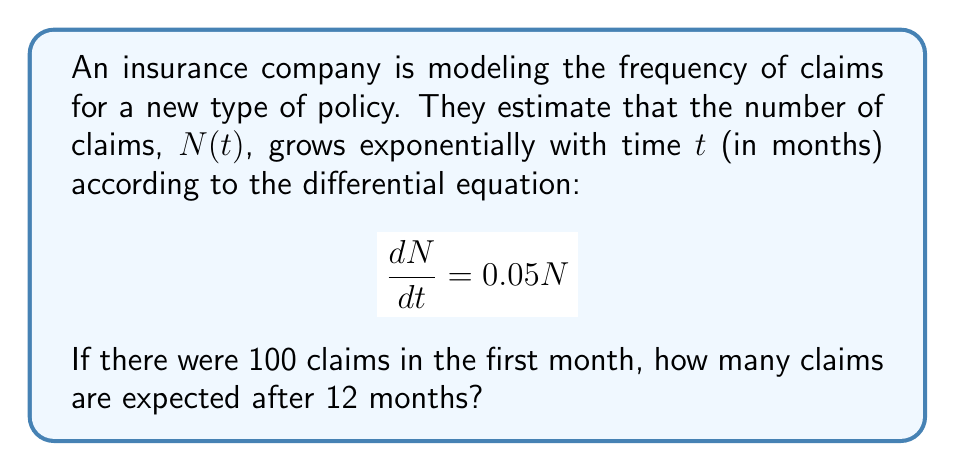Show me your answer to this math problem. Let's solve this step-by-step:

1) The given differential equation is:
   $$\frac{dN}{dt} = 0.05N$$

2) This is a separable first-order differential equation. We can solve it as follows:
   $$\frac{dN}{N} = 0.05dt$$

3) Integrating both sides:
   $$\int \frac{dN}{N} = \int 0.05dt$$
   $$\ln|N| = 0.05t + C$$

4) Taking the exponential of both sides:
   $$N = e^{0.05t + C} = e^C \cdot e^{0.05t}$$

5) Let $A = e^C$. Then our general solution is:
   $$N(t) = Ae^{0.05t}$$

6) We're given that $N(0) = 100$ (100 claims in the first month). Using this initial condition:
   $$100 = Ae^{0.05 \cdot 0} = A$$

7) So our particular solution is:
   $$N(t) = 100e^{0.05t}$$

8) To find the number of claims after 12 months, we evaluate $N(12)$:
   $$N(12) = 100e^{0.05 \cdot 12} = 100e^{0.6} \approx 182.21$$

Therefore, after 12 months, approximately 182 claims are expected.
Answer: 182 claims 